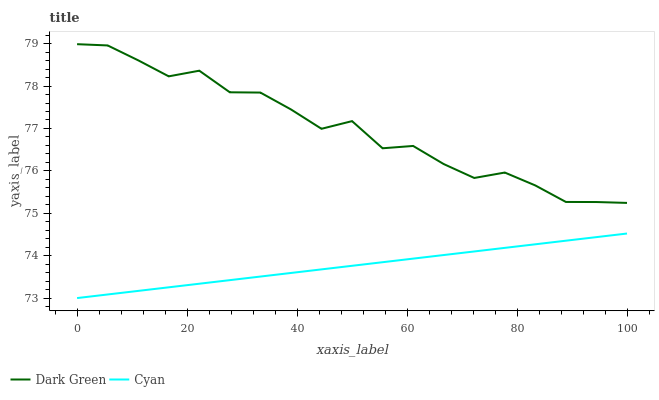Does Cyan have the minimum area under the curve?
Answer yes or no. Yes. Does Dark Green have the maximum area under the curve?
Answer yes or no. Yes. Does Dark Green have the minimum area under the curve?
Answer yes or no. No. Is Cyan the smoothest?
Answer yes or no. Yes. Is Dark Green the roughest?
Answer yes or no. Yes. Is Dark Green the smoothest?
Answer yes or no. No. Does Cyan have the lowest value?
Answer yes or no. Yes. Does Dark Green have the lowest value?
Answer yes or no. No. Does Dark Green have the highest value?
Answer yes or no. Yes. Is Cyan less than Dark Green?
Answer yes or no. Yes. Is Dark Green greater than Cyan?
Answer yes or no. Yes. Does Cyan intersect Dark Green?
Answer yes or no. No. 